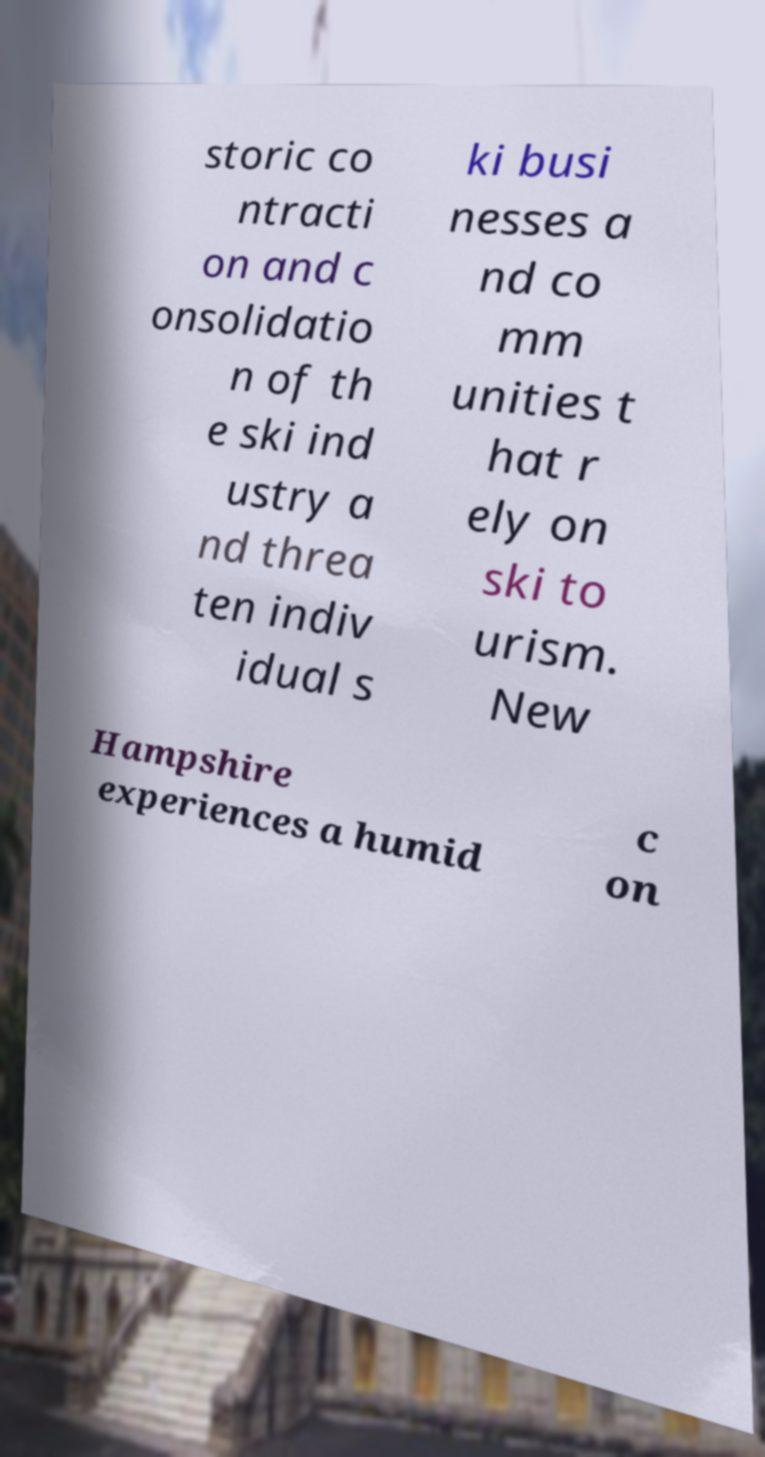Can you read and provide the text displayed in the image?This photo seems to have some interesting text. Can you extract and type it out for me? storic co ntracti on and c onsolidatio n of th e ski ind ustry a nd threa ten indiv idual s ki busi nesses a nd co mm unities t hat r ely on ski to urism. New Hampshire experiences a humid c on 